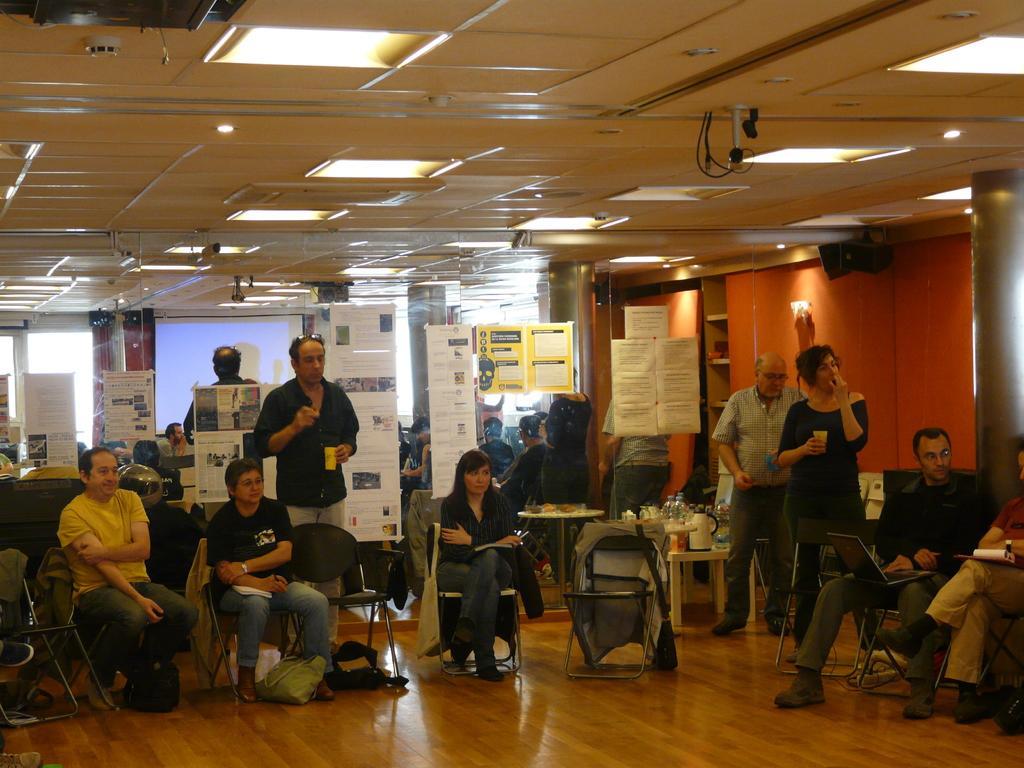How would you summarize this image in a sentence or two? In the image we can see there are people who are sitting on chair and other people are standing. 